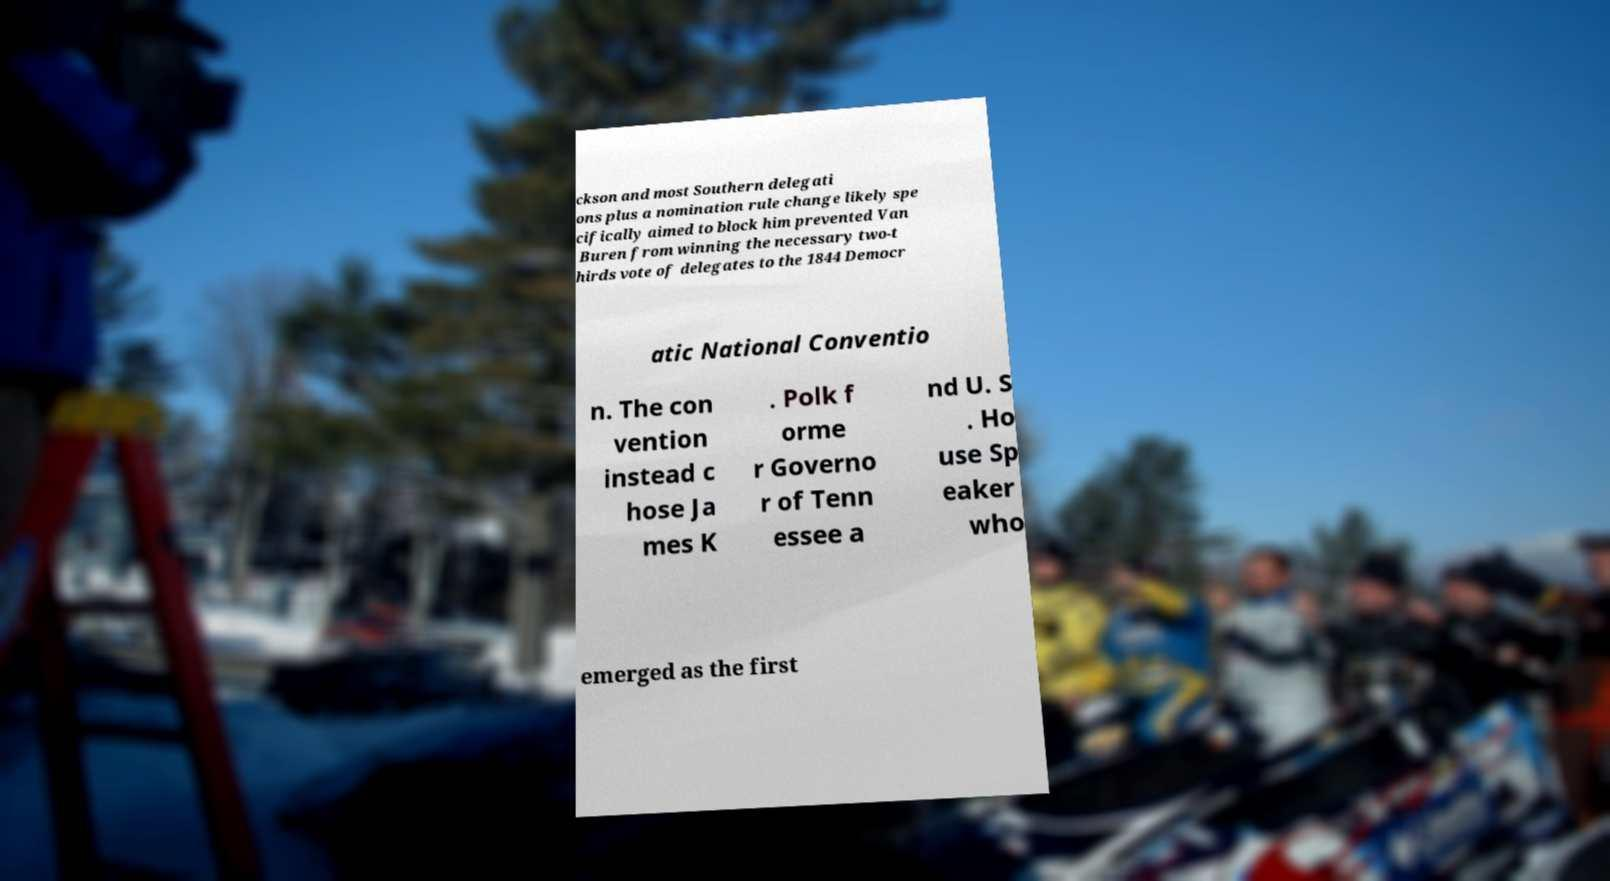Can you accurately transcribe the text from the provided image for me? ckson and most Southern delegati ons plus a nomination rule change likely spe cifically aimed to block him prevented Van Buren from winning the necessary two-t hirds vote of delegates to the 1844 Democr atic National Conventio n. The con vention instead c hose Ja mes K . Polk f orme r Governo r of Tenn essee a nd U. S . Ho use Sp eaker who emerged as the first 